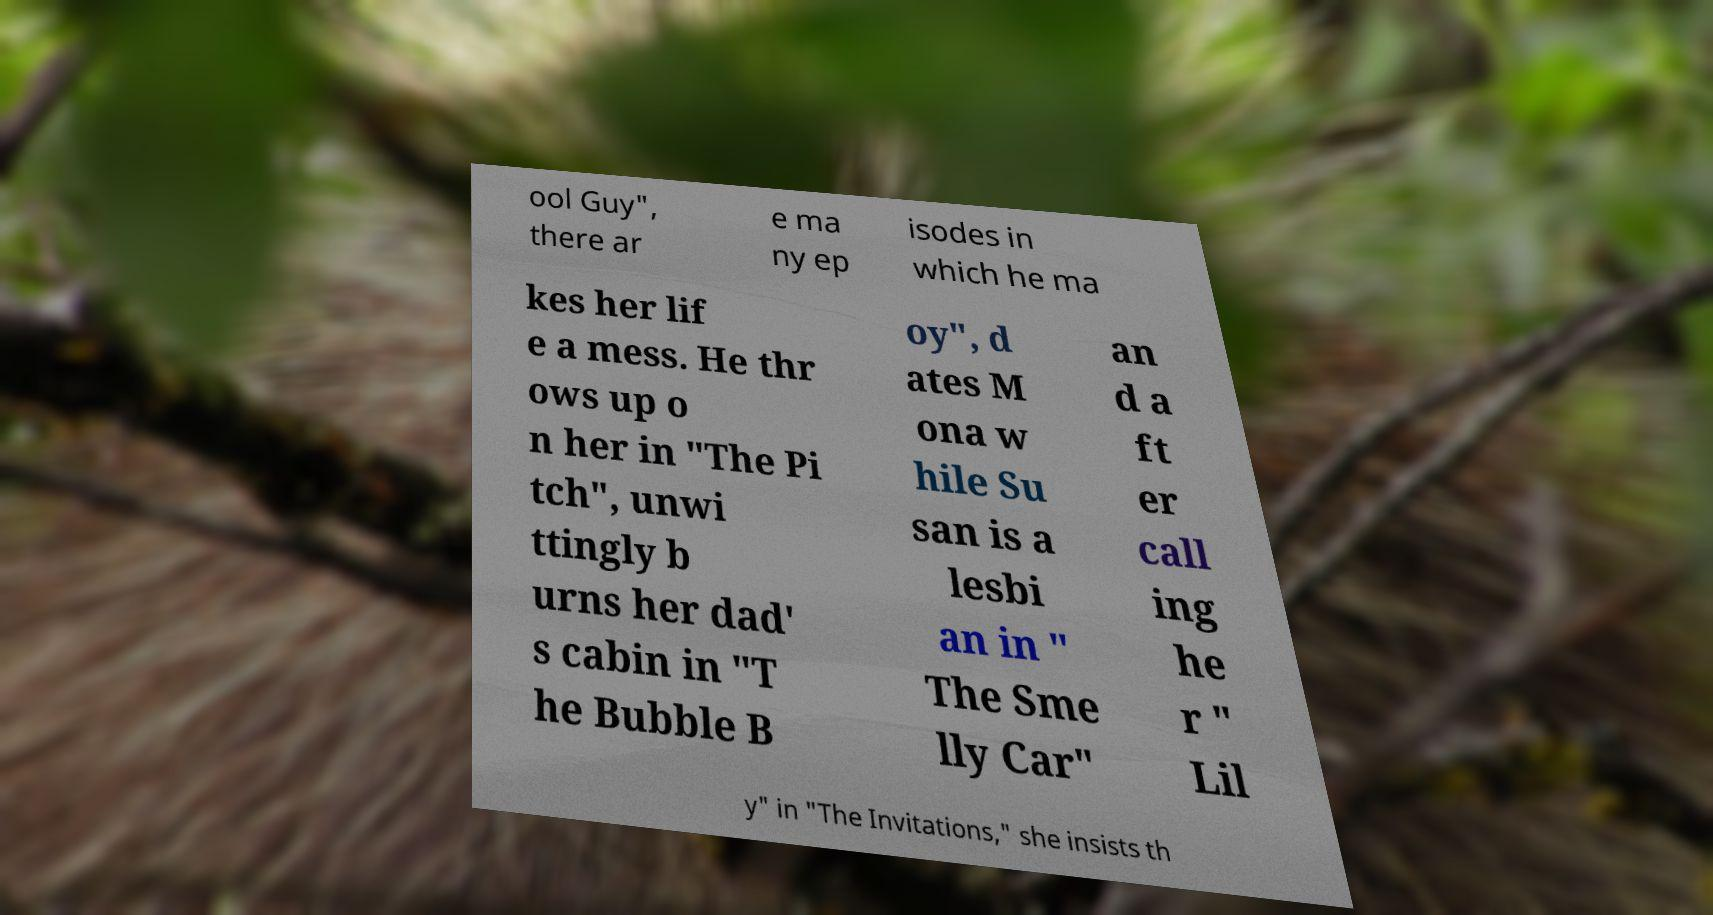Could you extract and type out the text from this image? ool Guy", there ar e ma ny ep isodes in which he ma kes her lif e a mess. He thr ows up o n her in "The Pi tch", unwi ttingly b urns her dad' s cabin in "T he Bubble B oy", d ates M ona w hile Su san is a lesbi an in " The Sme lly Car" an d a ft er call ing he r " Lil y" in "The Invitations," she insists th 